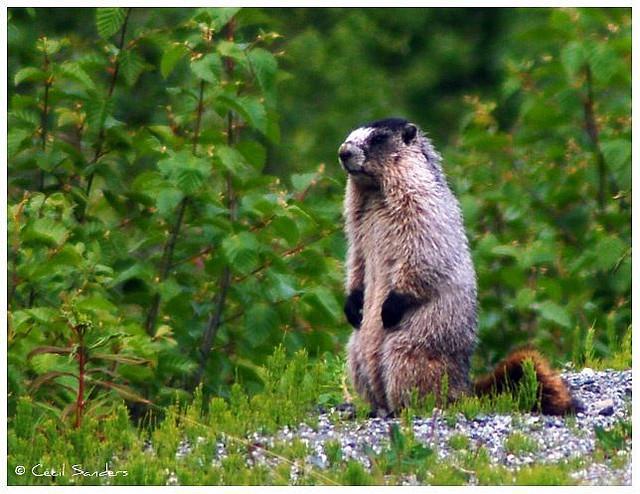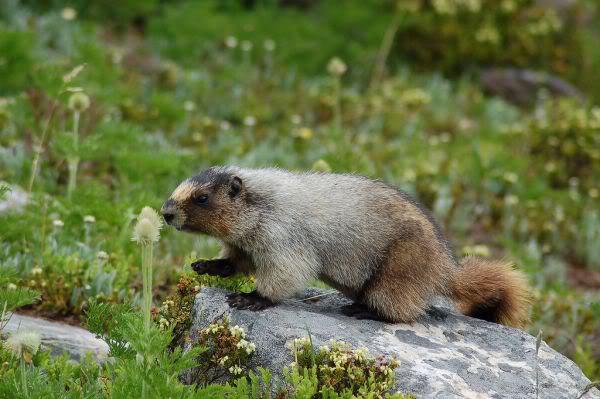The first image is the image on the left, the second image is the image on the right. For the images shown, is this caption "In one of the photos, the marmot's nose is near a blossom." true? Answer yes or no. Yes. The first image is the image on the left, the second image is the image on the right. For the images displayed, is the sentence "There is 1 or more woodchucks facing right." factually correct? Answer yes or no. No. 